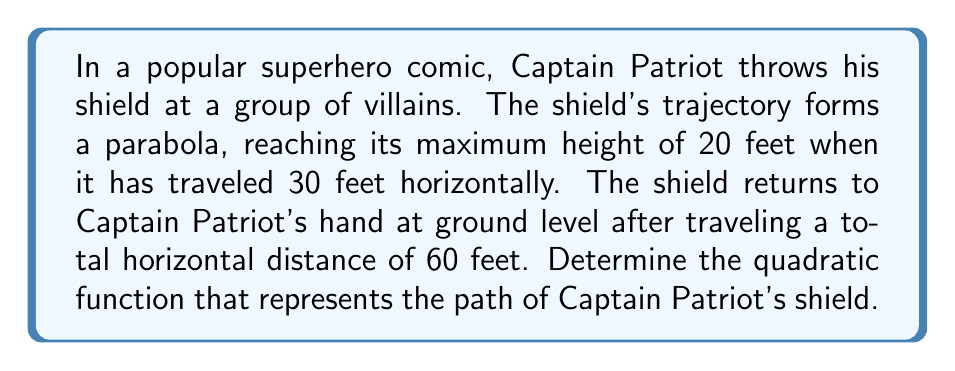Teach me how to tackle this problem. Let's approach this step-by-step:

1) The general form of a quadratic function is $f(x) = ax^2 + bx + c$, where $a$, $b$, and $c$ are constants and $a \neq 0$.

2) We know three points on this parabola:
   - (0, 0): The starting point
   - (30, 20): The maximum point
   - (60, 0): The ending point

3) Let's use the vertex form of a quadratic function: $f(x) = a(x-h)^2 + k$, where (h, k) is the vertex.

4) We know the vertex is (30, 20), so our function looks like:
   $f(x) = a(x-30)^2 + 20$

5) Now we can use either the starting or ending point to find $a$. Let's use (60, 0):

   $0 = a(60-30)^2 + 20$
   $0 = a(30)^2 + 20$
   $-20 = 900a$
   $a = -\frac{1}{45}$

6) Therefore, our quadratic function is:
   $f(x) = -\frac{1}{45}(x-30)^2 + 20$

7) To convert to standard form $(ax^2 + bx + c)$, we expand:

   $f(x) = -\frac{1}{45}(x^2 - 60x + 900) + 20$
   $f(x) = -\frac{1}{45}x^2 + \frac{4}{3}x - 20 + 20$

8) Simplifying:
   $f(x) = -\frac{1}{45}x^2 + \frac{4}{3}x$

This is the quadratic function representing the path of Captain Patriot's shield.
Answer: $f(x) = -\frac{1}{45}x^2 + \frac{4}{3}x$ 